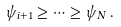<formula> <loc_0><loc_0><loc_500><loc_500>\psi _ { i + 1 } \geq \cdots \geq \psi _ { N } \, .</formula> 